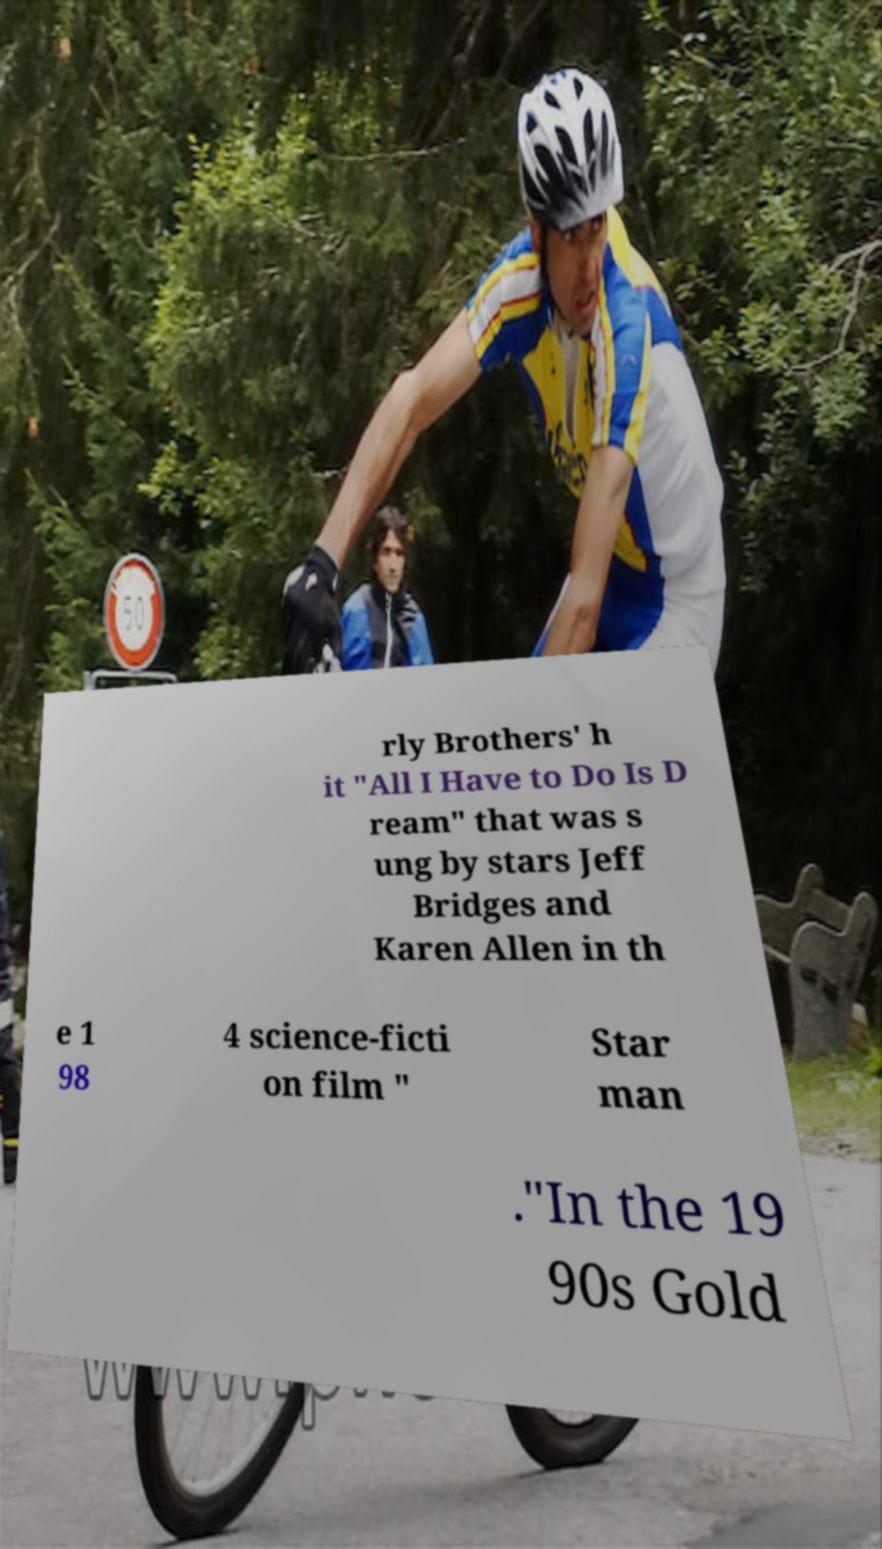There's text embedded in this image that I need extracted. Can you transcribe it verbatim? rly Brothers' h it "All I Have to Do Is D ream" that was s ung by stars Jeff Bridges and Karen Allen in th e 1 98 4 science-ficti on film " Star man ."In the 19 90s Gold 